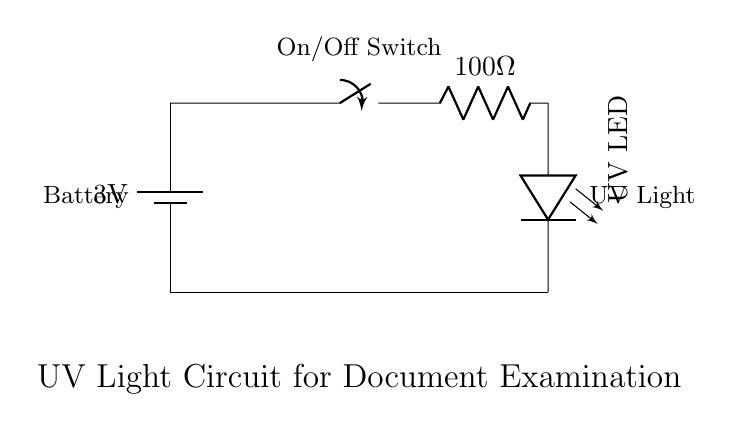What is the voltage of this circuit? The voltage is 3 volts, indicated by the battery label in the circuit diagram.
Answer: 3 volts What type of LED is used in this circuit? The circuit diagram shows a LED labeled as "UV LED," specifying the type of LED utilized for emitting ultraviolet light.
Answer: UV LED How many components are in this circuit? The circuit contains five components: a battery, a switch, a resistor, a UV LED, and grounding.
Answer: Five What is the resistance value in this circuit? The resistor is labeled with a value of 100 Ohms, denoting its resistance in the circuit.
Answer: 100 Ohms What happens when the switch is closed? Closing the switch completes the circuit, allowing current to flow from the battery through the resistor to the UV LED, thereby turning it on.
Answer: The UV LED lights up Explain the purpose of the resistor in this circuit. The resistor is intended to limit the current flowing to the UV LED. This prevents excessive current that could damage the LED, and is calculated based on the voltage and current specifications for safety.
Answer: To limit current 